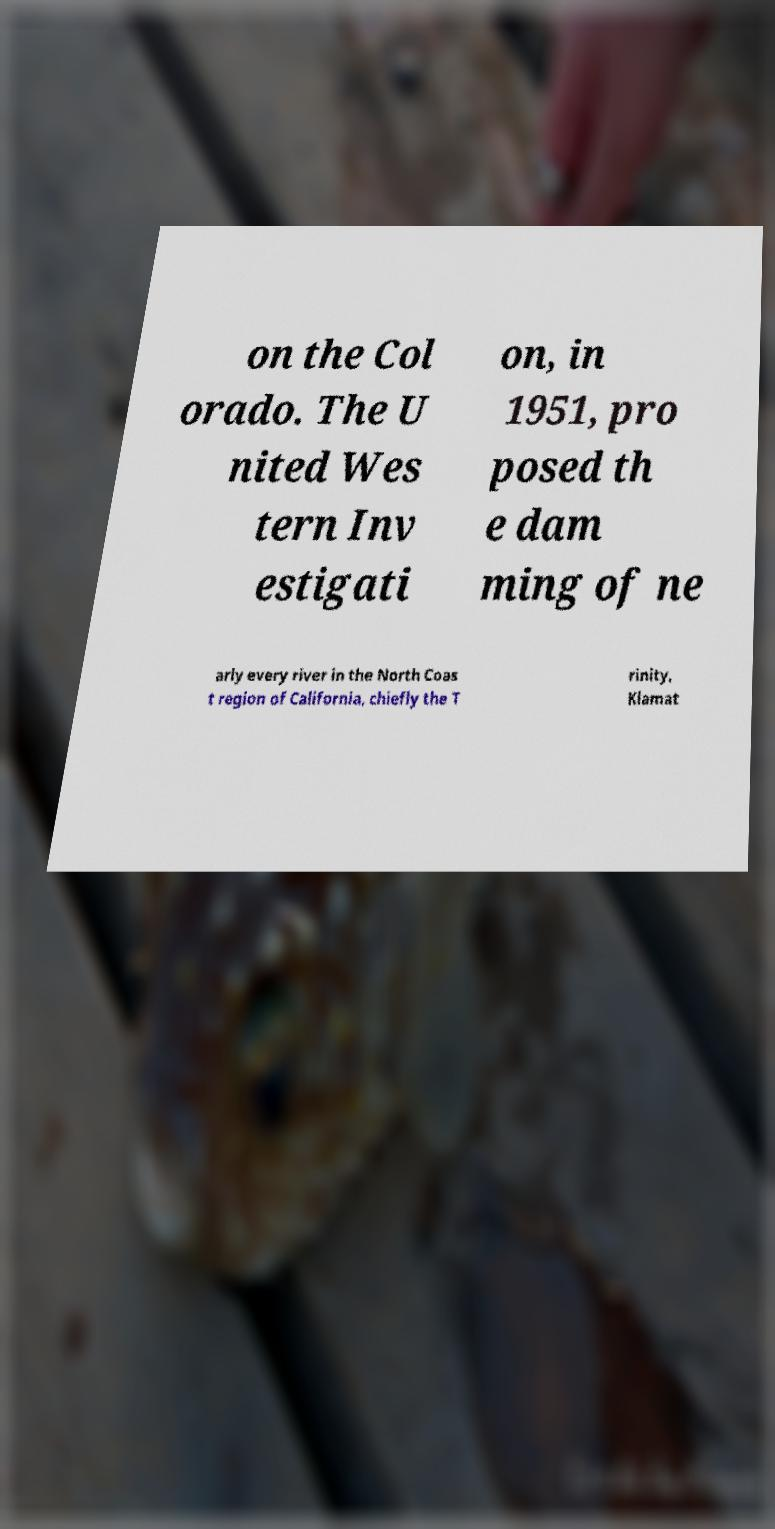Can you accurately transcribe the text from the provided image for me? on the Col orado. The U nited Wes tern Inv estigati on, in 1951, pro posed th e dam ming of ne arly every river in the North Coas t region of California, chiefly the T rinity, Klamat 